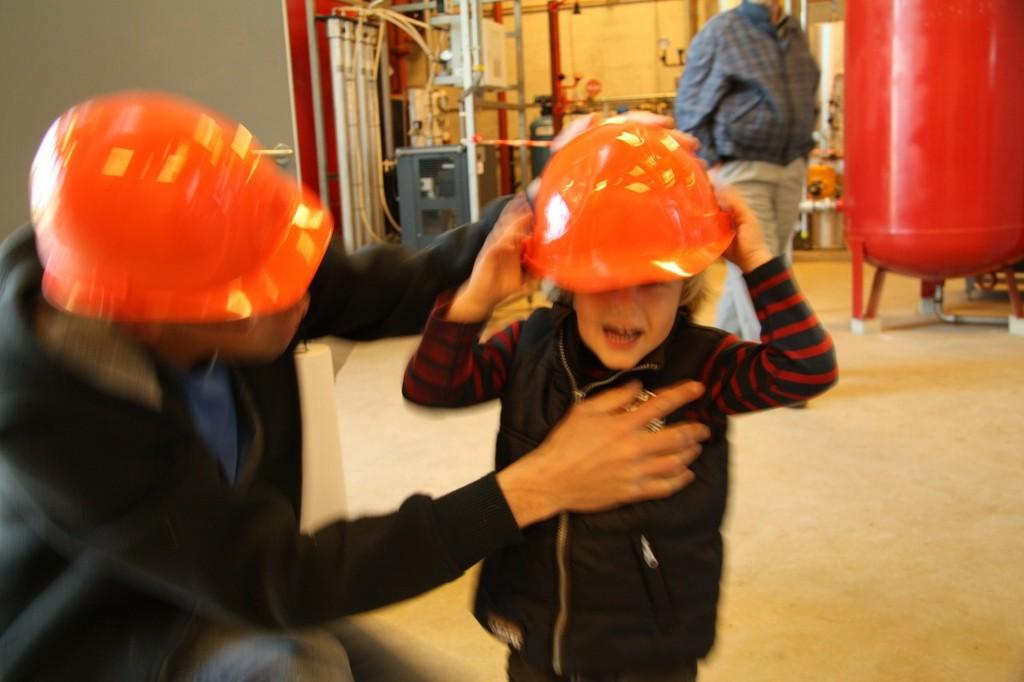What are the two people in the center of the image wearing on their heads? The two people in the center of the image are wearing helmets. What can be seen in the background of the image? In the background of the image, there is a wall, a tank, a person standing, poles, tools, and a few other objects. Can you describe the person standing in the background? The person standing in the background is not described in the provided facts. What type of objects are present in the background of the image? In the background of the image, there are poles, tools, and a few other objects. What type of jeans is the person wearing in the image? There is no information about jeans in the provided facts, so we cannot determine if anyone is wearing jeans in the image. Can you describe the locket that the person is holding in the image? There is no mention of a locket in the provided facts, so we cannot determine if anyone is holding a locket in the image. 